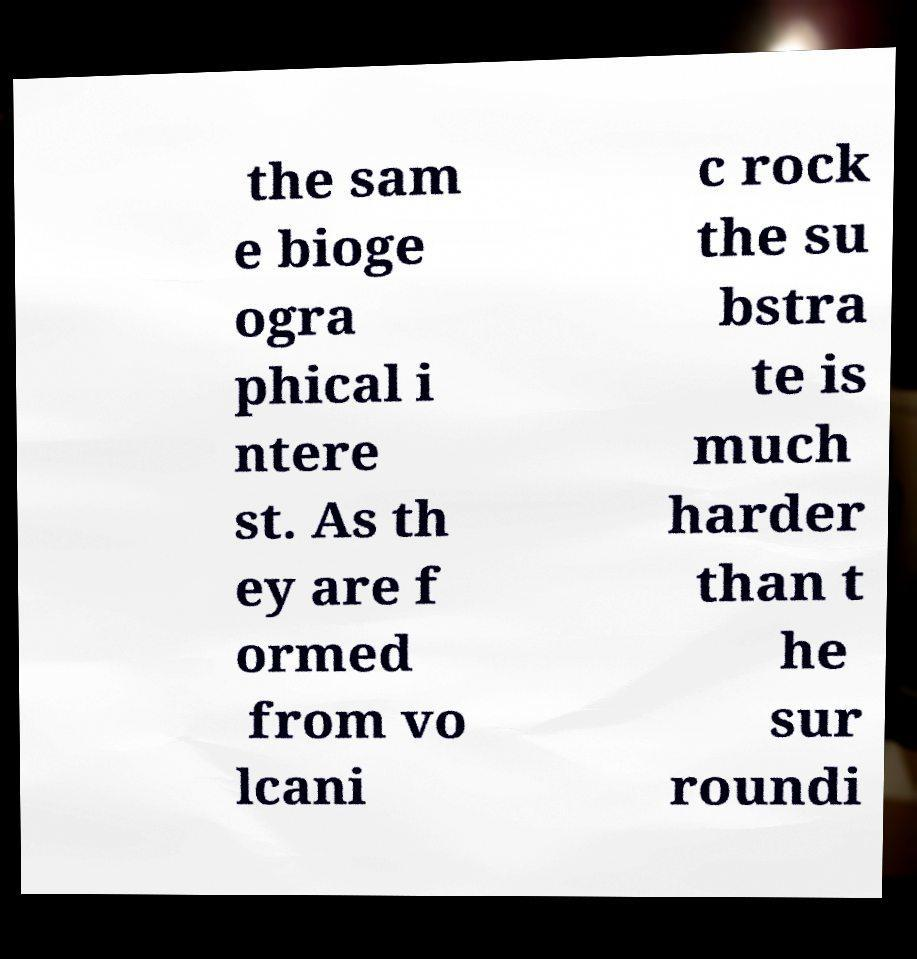There's text embedded in this image that I need extracted. Can you transcribe it verbatim? the sam e bioge ogra phical i ntere st. As th ey are f ormed from vo lcani c rock the su bstra te is much harder than t he sur roundi 